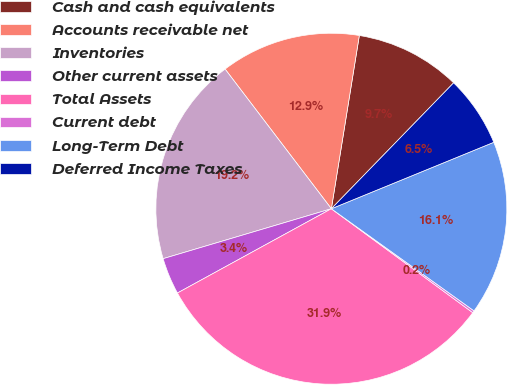Convert chart. <chart><loc_0><loc_0><loc_500><loc_500><pie_chart><fcel>Cash and cash equivalents<fcel>Accounts receivable net<fcel>Inventories<fcel>Other current assets<fcel>Total Assets<fcel>Current debt<fcel>Long-Term Debt<fcel>Deferred Income Taxes<nl><fcel>9.72%<fcel>12.9%<fcel>19.24%<fcel>3.38%<fcel>31.94%<fcel>0.2%<fcel>16.07%<fcel>6.55%<nl></chart> 